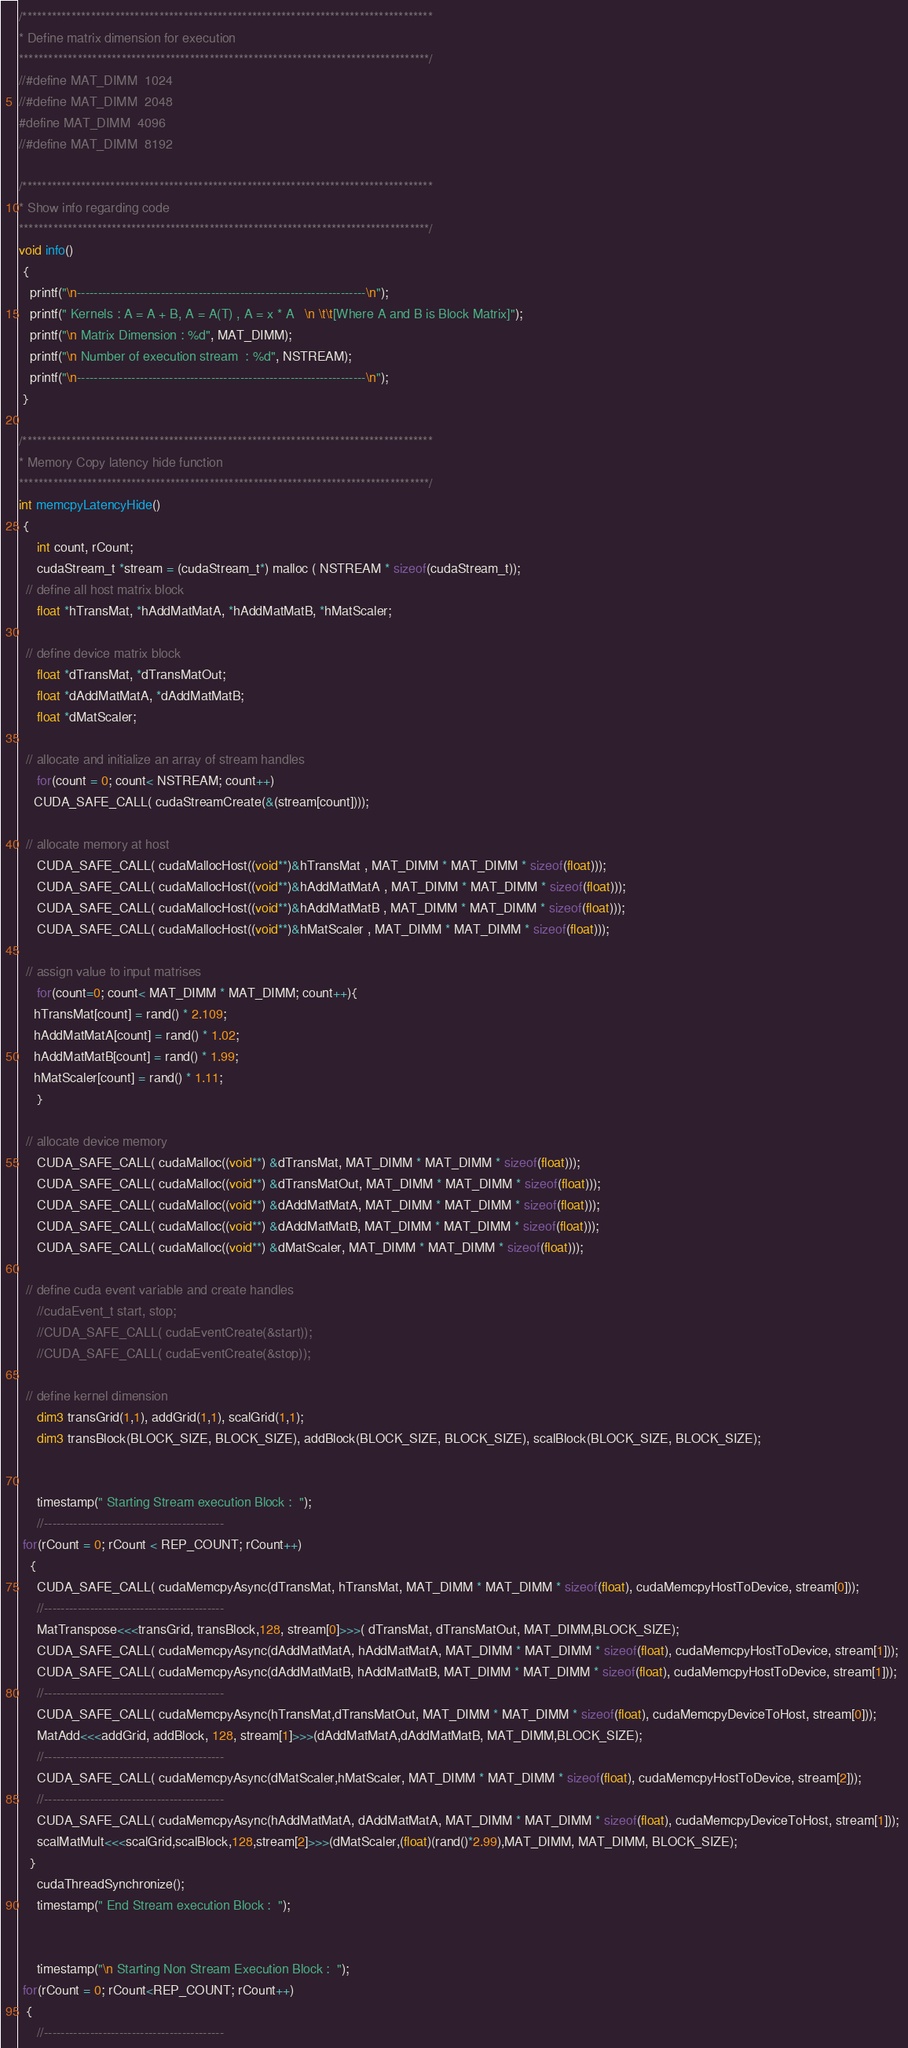Convert code to text. <code><loc_0><loc_0><loc_500><loc_500><_Cuda_>

/************************************************************************************
* Define matrix dimension for execution
************************************************************************************/
//#define MAT_DIMM  1024
//#define MAT_DIMM  2048
#define MAT_DIMM  4096
//#define MAT_DIMM  8192

/************************************************************************************
* Show info regarding code
************************************************************************************/
void info()
 {
   printf("\n---------------------------------------------------------------------\n");
   printf(" Kernels : A = A + B, A = A(T) , A = x * A   \n \t\t[Where A and B is Block Matrix]");
   printf("\n Matrix Dimension : %d", MAT_DIMM);
   printf("\n Number of execution stream  : %d", NSTREAM);
   printf("\n---------------------------------------------------------------------\n");
 }

/************************************************************************************
* Memory Copy latency hide function
************************************************************************************/
int memcpyLatencyHide()
 {
     int count, rCount;
     cudaStream_t *stream = (cudaStream_t*) malloc ( NSTREAM * sizeof(cudaStream_t));
  // define all host matrix block
     float *hTransMat, *hAddMatMatA, *hAddMatMatB, *hMatScaler;
  
  // define device matrix block
     float *dTransMat, *dTransMatOut; 
     float *dAddMatMatA, *dAddMatMatB;  
     float *dMatScaler; 	
    
  // allocate and initialize an array of stream handles
     for(count = 0; count< NSTREAM; count++)
	CUDA_SAFE_CALL( cudaStreamCreate(&(stream[count])));
 
  // allocate memory at host
     CUDA_SAFE_CALL( cudaMallocHost((void**)&hTransMat , MAT_DIMM * MAT_DIMM * sizeof(float)));
     CUDA_SAFE_CALL( cudaMallocHost((void**)&hAddMatMatA , MAT_DIMM * MAT_DIMM * sizeof(float)));
     CUDA_SAFE_CALL( cudaMallocHost((void**)&hAddMatMatB , MAT_DIMM * MAT_DIMM * sizeof(float)));
     CUDA_SAFE_CALL( cudaMallocHost((void**)&hMatScaler , MAT_DIMM * MAT_DIMM * sizeof(float)));

  // assign value to input matrises
     for(count=0; count< MAT_DIMM * MAT_DIMM; count++){
	hTransMat[count] = rand() * 2.109;
	hAddMatMatA[count] = rand() * 1.02;
	hAddMatMatB[count] = rand() * 1.99;
	hMatScaler[count] = rand() * 1.11;
     }
  
  // allocate device memory
     CUDA_SAFE_CALL( cudaMalloc((void**) &dTransMat, MAT_DIMM * MAT_DIMM * sizeof(float))); 
     CUDA_SAFE_CALL( cudaMalloc((void**) &dTransMatOut, MAT_DIMM * MAT_DIMM * sizeof(float))); 
     CUDA_SAFE_CALL( cudaMalloc((void**) &dAddMatMatA, MAT_DIMM * MAT_DIMM * sizeof(float))); 
     CUDA_SAFE_CALL( cudaMalloc((void**) &dAddMatMatB, MAT_DIMM * MAT_DIMM * sizeof(float))); 
     CUDA_SAFE_CALL( cudaMalloc((void**) &dMatScaler, MAT_DIMM * MAT_DIMM * sizeof(float))); 

  // define cuda event variable and create handles
     //cudaEvent_t start, stop;
     //CUDA_SAFE_CALL( cudaEventCreate(&start));
     //CUDA_SAFE_CALL( cudaEventCreate(&stop));
 
  // define kernel dimension 
     dim3 transGrid(1,1), addGrid(1,1), scalGrid(1,1);
     dim3 transBlock(BLOCK_SIZE, BLOCK_SIZE), addBlock(BLOCK_SIZE, BLOCK_SIZE), scalBlock(BLOCK_SIZE, BLOCK_SIZE);


     timestamp(" Starting Stream execution Block :  ");
     //-------------------------------------------
 for(rCount = 0; rCount < REP_COUNT; rCount++)
   {
     CUDA_SAFE_CALL( cudaMemcpyAsync(dTransMat, hTransMat, MAT_DIMM * MAT_DIMM * sizeof(float), cudaMemcpyHostToDevice, stream[0])); 
     //-------------------------------------------
     MatTranspose<<<transGrid, transBlock,128, stream[0]>>>( dTransMat, dTransMatOut, MAT_DIMM,BLOCK_SIZE);
     CUDA_SAFE_CALL( cudaMemcpyAsync(dAddMatMatA, hAddMatMatA, MAT_DIMM * MAT_DIMM * sizeof(float), cudaMemcpyHostToDevice, stream[1])); 
     CUDA_SAFE_CALL( cudaMemcpyAsync(dAddMatMatB, hAddMatMatB, MAT_DIMM * MAT_DIMM * sizeof(float), cudaMemcpyHostToDevice, stream[1])); 
     //-------------------------------------------
     CUDA_SAFE_CALL( cudaMemcpyAsync(hTransMat,dTransMatOut, MAT_DIMM * MAT_DIMM * sizeof(float), cudaMemcpyDeviceToHost, stream[0])); 
     MatAdd<<<addGrid, addBlock, 128, stream[1]>>>(dAddMatMatA,dAddMatMatB, MAT_DIMM,BLOCK_SIZE);
     //-------------------------------------------
     CUDA_SAFE_CALL( cudaMemcpyAsync(dMatScaler,hMatScaler, MAT_DIMM * MAT_DIMM * sizeof(float), cudaMemcpyHostToDevice, stream[2])); 
     //-------------------------------------------
     CUDA_SAFE_CALL( cudaMemcpyAsync(hAddMatMatA, dAddMatMatA, MAT_DIMM * MAT_DIMM * sizeof(float), cudaMemcpyDeviceToHost, stream[1])); 
     scalMatMult<<<scalGrid,scalBlock,128,stream[2]>>>(dMatScaler,(float)(rand()*2.99),MAT_DIMM, MAT_DIMM, BLOCK_SIZE);
   }
     cudaThreadSynchronize();
     timestamp(" End Stream execution Block :  ");
   
   
     timestamp("\n Starting Non Stream Execution Block :  ");
 for(rCount = 0; rCount<REP_COUNT; rCount++)
  {
     //-------------------------------------------</code> 